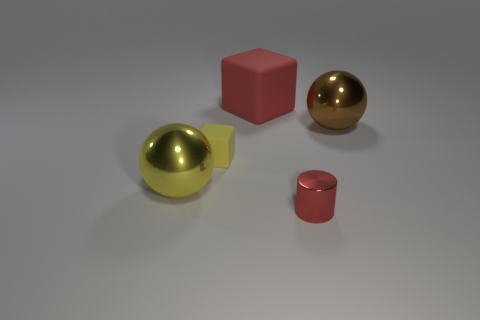Are there any red blocks that are in front of the shiny sphere right of the big rubber object?
Provide a succinct answer. No. There is a cylinder; is its size the same as the block that is on the right side of the tiny matte object?
Offer a very short reply. No. Is there a large brown sphere in front of the large metallic object that is behind the small object on the left side of the big rubber thing?
Offer a terse response. No. There is a block in front of the large brown ball; what is its material?
Your answer should be compact. Rubber. Is the size of the yellow ball the same as the cylinder?
Give a very brief answer. No. There is a big thing that is on the right side of the yellow metal sphere and left of the tiny red metal thing; what color is it?
Keep it short and to the point. Red. The red object that is made of the same material as the big brown object is what shape?
Offer a very short reply. Cylinder. What number of things are both to the left of the small yellow object and behind the brown thing?
Offer a terse response. 0. There is a large red block; are there any rubber things in front of it?
Offer a terse response. Yes. Do the red object that is behind the shiny cylinder and the tiny thing in front of the yellow rubber block have the same shape?
Ensure brevity in your answer.  No. 